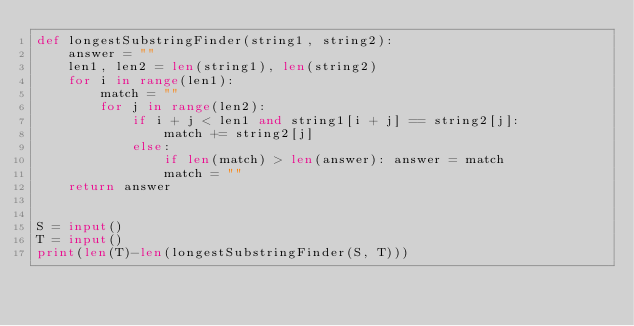Convert code to text. <code><loc_0><loc_0><loc_500><loc_500><_Python_>def longestSubstringFinder(string1, string2):
    answer = ""
    len1, len2 = len(string1), len(string2)
    for i in range(len1):
        match = ""
        for j in range(len2):
            if i + j < len1 and string1[i + j] == string2[j]:
                match += string2[j]
            else:
                if len(match) > len(answer): answer = match
                match = ""
    return answer


S = input()
T = input()
print(len(T)-len(longestSubstringFinder(S, T)))</code> 